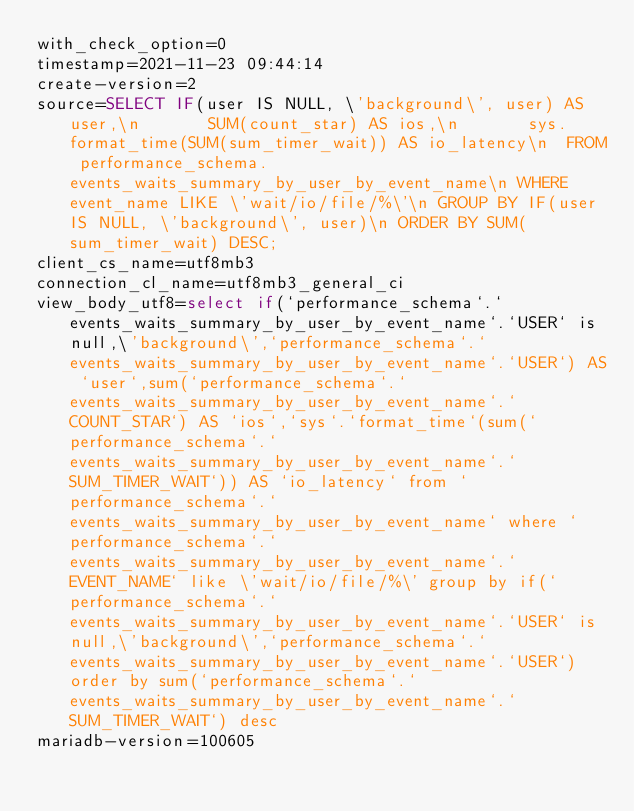Convert code to text. <code><loc_0><loc_0><loc_500><loc_500><_VisualBasic_>with_check_option=0
timestamp=2021-11-23 09:44:14
create-version=2
source=SELECT IF(user IS NULL, \'background\', user) AS user,\n       SUM(count_star) AS ios,\n       sys.format_time(SUM(sum_timer_wait)) AS io_latency\n  FROM performance_schema.events_waits_summary_by_user_by_event_name\n WHERE event_name LIKE \'wait/io/file/%\'\n GROUP BY IF(user IS NULL, \'background\', user)\n ORDER BY SUM(sum_timer_wait) DESC;
client_cs_name=utf8mb3
connection_cl_name=utf8mb3_general_ci
view_body_utf8=select if(`performance_schema`.`events_waits_summary_by_user_by_event_name`.`USER` is null,\'background\',`performance_schema`.`events_waits_summary_by_user_by_event_name`.`USER`) AS `user`,sum(`performance_schema`.`events_waits_summary_by_user_by_event_name`.`COUNT_STAR`) AS `ios`,`sys`.`format_time`(sum(`performance_schema`.`events_waits_summary_by_user_by_event_name`.`SUM_TIMER_WAIT`)) AS `io_latency` from `performance_schema`.`events_waits_summary_by_user_by_event_name` where `performance_schema`.`events_waits_summary_by_user_by_event_name`.`EVENT_NAME` like \'wait/io/file/%\' group by if(`performance_schema`.`events_waits_summary_by_user_by_event_name`.`USER` is null,\'background\',`performance_schema`.`events_waits_summary_by_user_by_event_name`.`USER`) order by sum(`performance_schema`.`events_waits_summary_by_user_by_event_name`.`SUM_TIMER_WAIT`) desc
mariadb-version=100605
</code> 